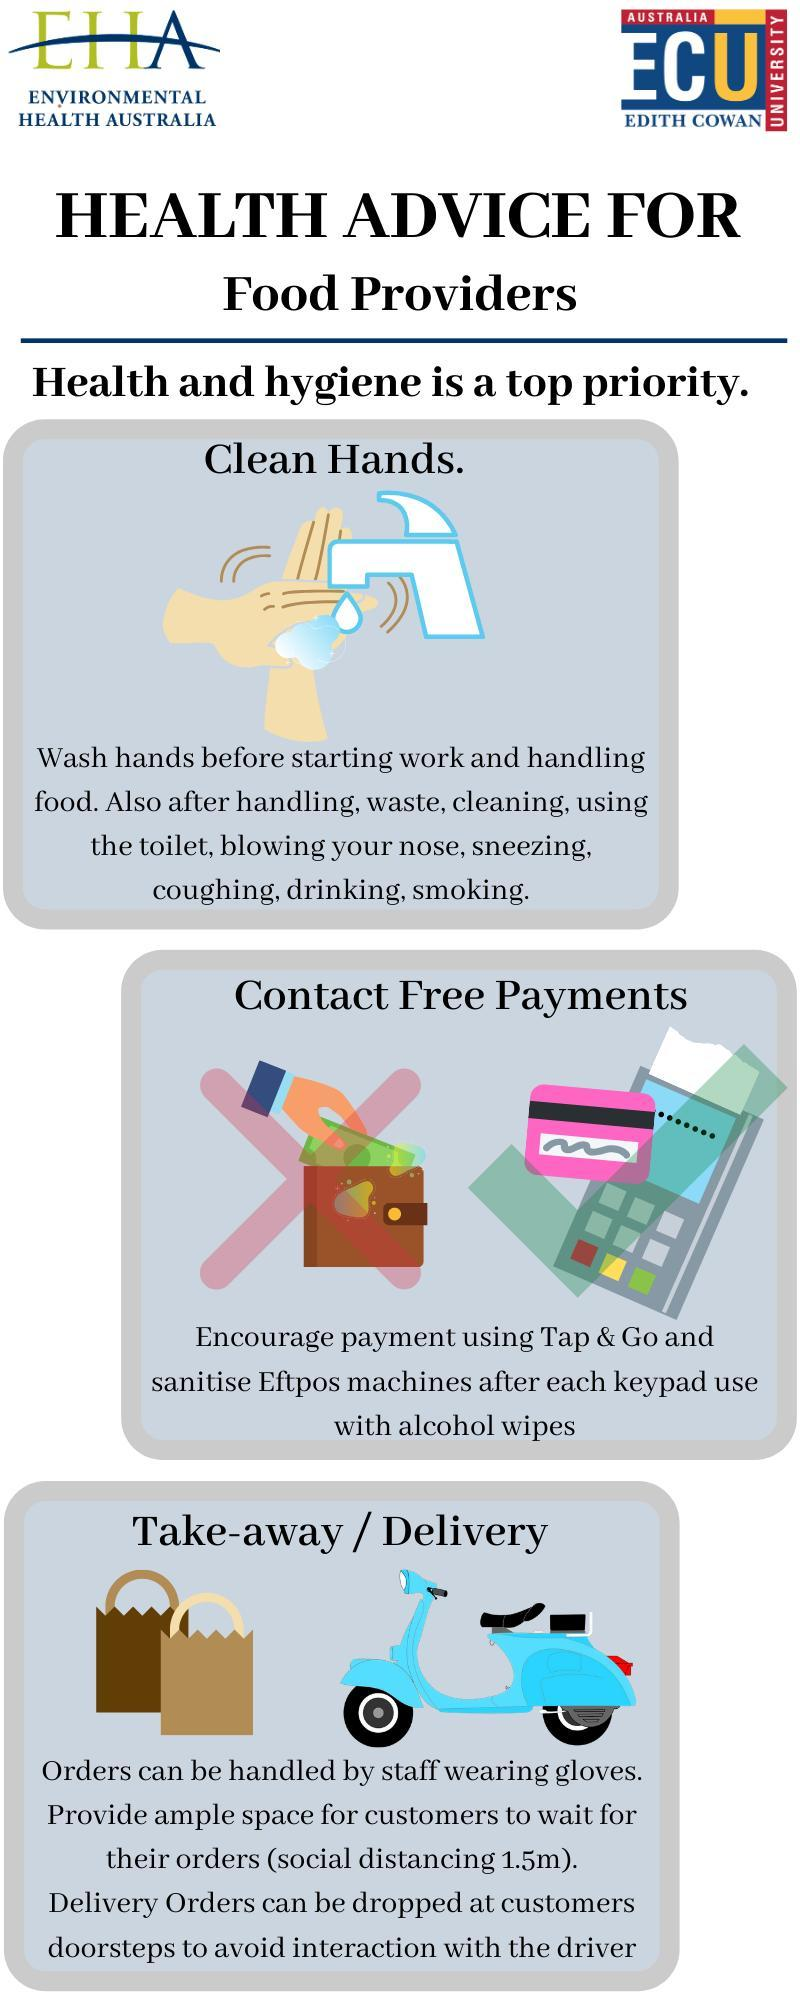What is the first major health advice and hygiene priority for food providers?
Answer the question with a short phrase. Clean Hands What is the third major health advice and hygiene priority for food providers? Take-away / Delivery What is the second major health advice and hygiene priority for food providers? Contact Free Payments 